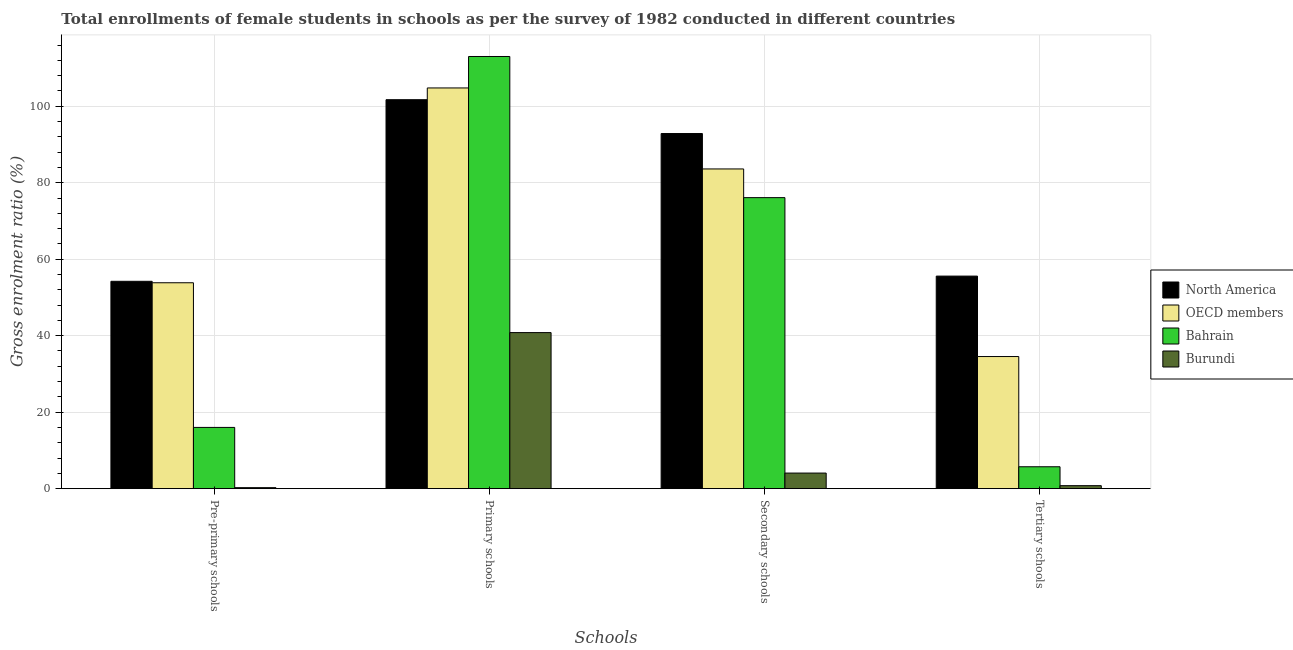Are the number of bars per tick equal to the number of legend labels?
Offer a terse response. Yes. How many bars are there on the 1st tick from the right?
Keep it short and to the point. 4. What is the label of the 4th group of bars from the left?
Ensure brevity in your answer.  Tertiary schools. What is the gross enrolment ratio(female) in primary schools in Burundi?
Keep it short and to the point. 40.81. Across all countries, what is the maximum gross enrolment ratio(female) in primary schools?
Provide a succinct answer. 113.01. Across all countries, what is the minimum gross enrolment ratio(female) in primary schools?
Give a very brief answer. 40.81. In which country was the gross enrolment ratio(female) in primary schools maximum?
Provide a short and direct response. Bahrain. In which country was the gross enrolment ratio(female) in secondary schools minimum?
Ensure brevity in your answer.  Burundi. What is the total gross enrolment ratio(female) in primary schools in the graph?
Offer a very short reply. 360.31. What is the difference between the gross enrolment ratio(female) in primary schools in North America and that in Burundi?
Ensure brevity in your answer.  60.9. What is the difference between the gross enrolment ratio(female) in primary schools in OECD members and the gross enrolment ratio(female) in secondary schools in Burundi?
Offer a very short reply. 100.7. What is the average gross enrolment ratio(female) in primary schools per country?
Make the answer very short. 90.08. What is the difference between the gross enrolment ratio(female) in tertiary schools and gross enrolment ratio(female) in pre-primary schools in Bahrain?
Your answer should be compact. -10.29. In how many countries, is the gross enrolment ratio(female) in pre-primary schools greater than 76 %?
Make the answer very short. 0. What is the ratio of the gross enrolment ratio(female) in secondary schools in North America to that in OECD members?
Give a very brief answer. 1.11. Is the difference between the gross enrolment ratio(female) in pre-primary schools in Burundi and North America greater than the difference between the gross enrolment ratio(female) in secondary schools in Burundi and North America?
Give a very brief answer. Yes. What is the difference between the highest and the second highest gross enrolment ratio(female) in pre-primary schools?
Your response must be concise. 0.38. What is the difference between the highest and the lowest gross enrolment ratio(female) in tertiary schools?
Provide a short and direct response. 54.8. In how many countries, is the gross enrolment ratio(female) in pre-primary schools greater than the average gross enrolment ratio(female) in pre-primary schools taken over all countries?
Make the answer very short. 2. Is it the case that in every country, the sum of the gross enrolment ratio(female) in primary schools and gross enrolment ratio(female) in pre-primary schools is greater than the sum of gross enrolment ratio(female) in secondary schools and gross enrolment ratio(female) in tertiary schools?
Your response must be concise. No. What does the 4th bar from the left in Primary schools represents?
Your answer should be very brief. Burundi. Are all the bars in the graph horizontal?
Keep it short and to the point. No. What is the difference between two consecutive major ticks on the Y-axis?
Your response must be concise. 20. Are the values on the major ticks of Y-axis written in scientific E-notation?
Make the answer very short. No. Does the graph contain any zero values?
Offer a very short reply. No. Does the graph contain grids?
Provide a short and direct response. Yes. What is the title of the graph?
Give a very brief answer. Total enrollments of female students in schools as per the survey of 1982 conducted in different countries. What is the label or title of the X-axis?
Offer a very short reply. Schools. What is the Gross enrolment ratio (%) in North America in Pre-primary schools?
Provide a succinct answer. 54.22. What is the Gross enrolment ratio (%) of OECD members in Pre-primary schools?
Ensure brevity in your answer.  53.84. What is the Gross enrolment ratio (%) of Bahrain in Pre-primary schools?
Keep it short and to the point. 16.02. What is the Gross enrolment ratio (%) in Burundi in Pre-primary schools?
Give a very brief answer. 0.26. What is the Gross enrolment ratio (%) of North America in Primary schools?
Provide a short and direct response. 101.71. What is the Gross enrolment ratio (%) of OECD members in Primary schools?
Your answer should be very brief. 104.78. What is the Gross enrolment ratio (%) of Bahrain in Primary schools?
Offer a terse response. 113.01. What is the Gross enrolment ratio (%) in Burundi in Primary schools?
Provide a succinct answer. 40.81. What is the Gross enrolment ratio (%) of North America in Secondary schools?
Keep it short and to the point. 92.86. What is the Gross enrolment ratio (%) in OECD members in Secondary schools?
Your answer should be compact. 83.6. What is the Gross enrolment ratio (%) of Bahrain in Secondary schools?
Your response must be concise. 76.1. What is the Gross enrolment ratio (%) of Burundi in Secondary schools?
Make the answer very short. 4.08. What is the Gross enrolment ratio (%) of North America in Tertiary schools?
Provide a succinct answer. 55.58. What is the Gross enrolment ratio (%) of OECD members in Tertiary schools?
Offer a terse response. 34.55. What is the Gross enrolment ratio (%) in Bahrain in Tertiary schools?
Your answer should be very brief. 5.73. What is the Gross enrolment ratio (%) in Burundi in Tertiary schools?
Offer a terse response. 0.79. Across all Schools, what is the maximum Gross enrolment ratio (%) of North America?
Provide a succinct answer. 101.71. Across all Schools, what is the maximum Gross enrolment ratio (%) in OECD members?
Keep it short and to the point. 104.78. Across all Schools, what is the maximum Gross enrolment ratio (%) of Bahrain?
Keep it short and to the point. 113.01. Across all Schools, what is the maximum Gross enrolment ratio (%) in Burundi?
Ensure brevity in your answer.  40.81. Across all Schools, what is the minimum Gross enrolment ratio (%) in North America?
Offer a very short reply. 54.22. Across all Schools, what is the minimum Gross enrolment ratio (%) of OECD members?
Give a very brief answer. 34.55. Across all Schools, what is the minimum Gross enrolment ratio (%) in Bahrain?
Provide a succinct answer. 5.73. Across all Schools, what is the minimum Gross enrolment ratio (%) in Burundi?
Your answer should be compact. 0.26. What is the total Gross enrolment ratio (%) of North America in the graph?
Offer a terse response. 304.38. What is the total Gross enrolment ratio (%) in OECD members in the graph?
Your answer should be very brief. 276.78. What is the total Gross enrolment ratio (%) of Bahrain in the graph?
Make the answer very short. 210.86. What is the total Gross enrolment ratio (%) in Burundi in the graph?
Make the answer very short. 45.94. What is the difference between the Gross enrolment ratio (%) in North America in Pre-primary schools and that in Primary schools?
Offer a terse response. -47.49. What is the difference between the Gross enrolment ratio (%) of OECD members in Pre-primary schools and that in Primary schools?
Make the answer very short. -50.94. What is the difference between the Gross enrolment ratio (%) in Bahrain in Pre-primary schools and that in Primary schools?
Make the answer very short. -96.99. What is the difference between the Gross enrolment ratio (%) of Burundi in Pre-primary schools and that in Primary schools?
Make the answer very short. -40.55. What is the difference between the Gross enrolment ratio (%) in North America in Pre-primary schools and that in Secondary schools?
Offer a terse response. -38.64. What is the difference between the Gross enrolment ratio (%) in OECD members in Pre-primary schools and that in Secondary schools?
Give a very brief answer. -29.76. What is the difference between the Gross enrolment ratio (%) in Bahrain in Pre-primary schools and that in Secondary schools?
Make the answer very short. -60.08. What is the difference between the Gross enrolment ratio (%) in Burundi in Pre-primary schools and that in Secondary schools?
Provide a succinct answer. -3.82. What is the difference between the Gross enrolment ratio (%) in North America in Pre-primary schools and that in Tertiary schools?
Your response must be concise. -1.36. What is the difference between the Gross enrolment ratio (%) in OECD members in Pre-primary schools and that in Tertiary schools?
Offer a terse response. 19.29. What is the difference between the Gross enrolment ratio (%) of Bahrain in Pre-primary schools and that in Tertiary schools?
Your answer should be very brief. 10.29. What is the difference between the Gross enrolment ratio (%) of Burundi in Pre-primary schools and that in Tertiary schools?
Offer a very short reply. -0.52. What is the difference between the Gross enrolment ratio (%) in North America in Primary schools and that in Secondary schools?
Your answer should be very brief. 8.85. What is the difference between the Gross enrolment ratio (%) in OECD members in Primary schools and that in Secondary schools?
Give a very brief answer. 21.18. What is the difference between the Gross enrolment ratio (%) of Bahrain in Primary schools and that in Secondary schools?
Your response must be concise. 36.91. What is the difference between the Gross enrolment ratio (%) of Burundi in Primary schools and that in Secondary schools?
Your answer should be compact. 36.73. What is the difference between the Gross enrolment ratio (%) in North America in Primary schools and that in Tertiary schools?
Offer a very short reply. 46.13. What is the difference between the Gross enrolment ratio (%) of OECD members in Primary schools and that in Tertiary schools?
Make the answer very short. 70.23. What is the difference between the Gross enrolment ratio (%) of Bahrain in Primary schools and that in Tertiary schools?
Offer a very short reply. 107.28. What is the difference between the Gross enrolment ratio (%) in Burundi in Primary schools and that in Tertiary schools?
Your answer should be very brief. 40.02. What is the difference between the Gross enrolment ratio (%) of North America in Secondary schools and that in Tertiary schools?
Provide a short and direct response. 37.28. What is the difference between the Gross enrolment ratio (%) in OECD members in Secondary schools and that in Tertiary schools?
Ensure brevity in your answer.  49.05. What is the difference between the Gross enrolment ratio (%) of Bahrain in Secondary schools and that in Tertiary schools?
Give a very brief answer. 70.37. What is the difference between the Gross enrolment ratio (%) of Burundi in Secondary schools and that in Tertiary schools?
Give a very brief answer. 3.3. What is the difference between the Gross enrolment ratio (%) in North America in Pre-primary schools and the Gross enrolment ratio (%) in OECD members in Primary schools?
Your answer should be compact. -50.56. What is the difference between the Gross enrolment ratio (%) of North America in Pre-primary schools and the Gross enrolment ratio (%) of Bahrain in Primary schools?
Provide a short and direct response. -58.79. What is the difference between the Gross enrolment ratio (%) of North America in Pre-primary schools and the Gross enrolment ratio (%) of Burundi in Primary schools?
Offer a very short reply. 13.41. What is the difference between the Gross enrolment ratio (%) in OECD members in Pre-primary schools and the Gross enrolment ratio (%) in Bahrain in Primary schools?
Offer a terse response. -59.17. What is the difference between the Gross enrolment ratio (%) in OECD members in Pre-primary schools and the Gross enrolment ratio (%) in Burundi in Primary schools?
Keep it short and to the point. 13.03. What is the difference between the Gross enrolment ratio (%) of Bahrain in Pre-primary schools and the Gross enrolment ratio (%) of Burundi in Primary schools?
Your answer should be compact. -24.79. What is the difference between the Gross enrolment ratio (%) in North America in Pre-primary schools and the Gross enrolment ratio (%) in OECD members in Secondary schools?
Make the answer very short. -29.38. What is the difference between the Gross enrolment ratio (%) in North America in Pre-primary schools and the Gross enrolment ratio (%) in Bahrain in Secondary schools?
Your answer should be very brief. -21.88. What is the difference between the Gross enrolment ratio (%) in North America in Pre-primary schools and the Gross enrolment ratio (%) in Burundi in Secondary schools?
Keep it short and to the point. 50.14. What is the difference between the Gross enrolment ratio (%) of OECD members in Pre-primary schools and the Gross enrolment ratio (%) of Bahrain in Secondary schools?
Keep it short and to the point. -22.26. What is the difference between the Gross enrolment ratio (%) of OECD members in Pre-primary schools and the Gross enrolment ratio (%) of Burundi in Secondary schools?
Keep it short and to the point. 49.76. What is the difference between the Gross enrolment ratio (%) in Bahrain in Pre-primary schools and the Gross enrolment ratio (%) in Burundi in Secondary schools?
Make the answer very short. 11.94. What is the difference between the Gross enrolment ratio (%) in North America in Pre-primary schools and the Gross enrolment ratio (%) in OECD members in Tertiary schools?
Ensure brevity in your answer.  19.67. What is the difference between the Gross enrolment ratio (%) in North America in Pre-primary schools and the Gross enrolment ratio (%) in Bahrain in Tertiary schools?
Your response must be concise. 48.49. What is the difference between the Gross enrolment ratio (%) of North America in Pre-primary schools and the Gross enrolment ratio (%) of Burundi in Tertiary schools?
Your response must be concise. 53.44. What is the difference between the Gross enrolment ratio (%) of OECD members in Pre-primary schools and the Gross enrolment ratio (%) of Bahrain in Tertiary schools?
Give a very brief answer. 48.11. What is the difference between the Gross enrolment ratio (%) in OECD members in Pre-primary schools and the Gross enrolment ratio (%) in Burundi in Tertiary schools?
Provide a short and direct response. 53.06. What is the difference between the Gross enrolment ratio (%) of Bahrain in Pre-primary schools and the Gross enrolment ratio (%) of Burundi in Tertiary schools?
Give a very brief answer. 15.23. What is the difference between the Gross enrolment ratio (%) in North America in Primary schools and the Gross enrolment ratio (%) in OECD members in Secondary schools?
Keep it short and to the point. 18.11. What is the difference between the Gross enrolment ratio (%) of North America in Primary schools and the Gross enrolment ratio (%) of Bahrain in Secondary schools?
Give a very brief answer. 25.61. What is the difference between the Gross enrolment ratio (%) in North America in Primary schools and the Gross enrolment ratio (%) in Burundi in Secondary schools?
Offer a terse response. 97.63. What is the difference between the Gross enrolment ratio (%) of OECD members in Primary schools and the Gross enrolment ratio (%) of Bahrain in Secondary schools?
Your answer should be very brief. 28.68. What is the difference between the Gross enrolment ratio (%) in OECD members in Primary schools and the Gross enrolment ratio (%) in Burundi in Secondary schools?
Provide a short and direct response. 100.7. What is the difference between the Gross enrolment ratio (%) of Bahrain in Primary schools and the Gross enrolment ratio (%) of Burundi in Secondary schools?
Ensure brevity in your answer.  108.93. What is the difference between the Gross enrolment ratio (%) in North America in Primary schools and the Gross enrolment ratio (%) in OECD members in Tertiary schools?
Provide a succinct answer. 67.16. What is the difference between the Gross enrolment ratio (%) of North America in Primary schools and the Gross enrolment ratio (%) of Bahrain in Tertiary schools?
Offer a very short reply. 95.98. What is the difference between the Gross enrolment ratio (%) in North America in Primary schools and the Gross enrolment ratio (%) in Burundi in Tertiary schools?
Provide a succinct answer. 100.92. What is the difference between the Gross enrolment ratio (%) of OECD members in Primary schools and the Gross enrolment ratio (%) of Bahrain in Tertiary schools?
Give a very brief answer. 99.05. What is the difference between the Gross enrolment ratio (%) in OECD members in Primary schools and the Gross enrolment ratio (%) in Burundi in Tertiary schools?
Your answer should be compact. 104. What is the difference between the Gross enrolment ratio (%) of Bahrain in Primary schools and the Gross enrolment ratio (%) of Burundi in Tertiary schools?
Give a very brief answer. 112.22. What is the difference between the Gross enrolment ratio (%) of North America in Secondary schools and the Gross enrolment ratio (%) of OECD members in Tertiary schools?
Make the answer very short. 58.31. What is the difference between the Gross enrolment ratio (%) in North America in Secondary schools and the Gross enrolment ratio (%) in Bahrain in Tertiary schools?
Ensure brevity in your answer.  87.13. What is the difference between the Gross enrolment ratio (%) in North America in Secondary schools and the Gross enrolment ratio (%) in Burundi in Tertiary schools?
Make the answer very short. 92.07. What is the difference between the Gross enrolment ratio (%) in OECD members in Secondary schools and the Gross enrolment ratio (%) in Bahrain in Tertiary schools?
Your answer should be very brief. 77.87. What is the difference between the Gross enrolment ratio (%) of OECD members in Secondary schools and the Gross enrolment ratio (%) of Burundi in Tertiary schools?
Provide a succinct answer. 82.82. What is the difference between the Gross enrolment ratio (%) in Bahrain in Secondary schools and the Gross enrolment ratio (%) in Burundi in Tertiary schools?
Ensure brevity in your answer.  75.32. What is the average Gross enrolment ratio (%) of North America per Schools?
Ensure brevity in your answer.  76.09. What is the average Gross enrolment ratio (%) in OECD members per Schools?
Provide a succinct answer. 69.2. What is the average Gross enrolment ratio (%) in Bahrain per Schools?
Offer a very short reply. 52.72. What is the average Gross enrolment ratio (%) of Burundi per Schools?
Give a very brief answer. 11.49. What is the difference between the Gross enrolment ratio (%) of North America and Gross enrolment ratio (%) of OECD members in Pre-primary schools?
Provide a short and direct response. 0.38. What is the difference between the Gross enrolment ratio (%) in North America and Gross enrolment ratio (%) in Bahrain in Pre-primary schools?
Give a very brief answer. 38.2. What is the difference between the Gross enrolment ratio (%) of North America and Gross enrolment ratio (%) of Burundi in Pre-primary schools?
Make the answer very short. 53.96. What is the difference between the Gross enrolment ratio (%) in OECD members and Gross enrolment ratio (%) in Bahrain in Pre-primary schools?
Give a very brief answer. 37.82. What is the difference between the Gross enrolment ratio (%) of OECD members and Gross enrolment ratio (%) of Burundi in Pre-primary schools?
Give a very brief answer. 53.58. What is the difference between the Gross enrolment ratio (%) in Bahrain and Gross enrolment ratio (%) in Burundi in Pre-primary schools?
Offer a terse response. 15.76. What is the difference between the Gross enrolment ratio (%) in North America and Gross enrolment ratio (%) in OECD members in Primary schools?
Offer a terse response. -3.07. What is the difference between the Gross enrolment ratio (%) of North America and Gross enrolment ratio (%) of Bahrain in Primary schools?
Ensure brevity in your answer.  -11.3. What is the difference between the Gross enrolment ratio (%) of North America and Gross enrolment ratio (%) of Burundi in Primary schools?
Provide a succinct answer. 60.9. What is the difference between the Gross enrolment ratio (%) of OECD members and Gross enrolment ratio (%) of Bahrain in Primary schools?
Your answer should be compact. -8.23. What is the difference between the Gross enrolment ratio (%) in OECD members and Gross enrolment ratio (%) in Burundi in Primary schools?
Your response must be concise. 63.97. What is the difference between the Gross enrolment ratio (%) in Bahrain and Gross enrolment ratio (%) in Burundi in Primary schools?
Provide a succinct answer. 72.2. What is the difference between the Gross enrolment ratio (%) of North America and Gross enrolment ratio (%) of OECD members in Secondary schools?
Provide a succinct answer. 9.26. What is the difference between the Gross enrolment ratio (%) in North America and Gross enrolment ratio (%) in Bahrain in Secondary schools?
Keep it short and to the point. 16.76. What is the difference between the Gross enrolment ratio (%) in North America and Gross enrolment ratio (%) in Burundi in Secondary schools?
Keep it short and to the point. 88.78. What is the difference between the Gross enrolment ratio (%) of OECD members and Gross enrolment ratio (%) of Bahrain in Secondary schools?
Your response must be concise. 7.5. What is the difference between the Gross enrolment ratio (%) of OECD members and Gross enrolment ratio (%) of Burundi in Secondary schools?
Give a very brief answer. 79.52. What is the difference between the Gross enrolment ratio (%) of Bahrain and Gross enrolment ratio (%) of Burundi in Secondary schools?
Make the answer very short. 72.02. What is the difference between the Gross enrolment ratio (%) in North America and Gross enrolment ratio (%) in OECD members in Tertiary schools?
Provide a succinct answer. 21.03. What is the difference between the Gross enrolment ratio (%) in North America and Gross enrolment ratio (%) in Bahrain in Tertiary schools?
Give a very brief answer. 49.85. What is the difference between the Gross enrolment ratio (%) of North America and Gross enrolment ratio (%) of Burundi in Tertiary schools?
Offer a terse response. 54.8. What is the difference between the Gross enrolment ratio (%) in OECD members and Gross enrolment ratio (%) in Bahrain in Tertiary schools?
Provide a short and direct response. 28.82. What is the difference between the Gross enrolment ratio (%) of OECD members and Gross enrolment ratio (%) of Burundi in Tertiary schools?
Your answer should be compact. 33.76. What is the difference between the Gross enrolment ratio (%) of Bahrain and Gross enrolment ratio (%) of Burundi in Tertiary schools?
Your response must be concise. 4.94. What is the ratio of the Gross enrolment ratio (%) of North America in Pre-primary schools to that in Primary schools?
Ensure brevity in your answer.  0.53. What is the ratio of the Gross enrolment ratio (%) in OECD members in Pre-primary schools to that in Primary schools?
Your response must be concise. 0.51. What is the ratio of the Gross enrolment ratio (%) in Bahrain in Pre-primary schools to that in Primary schools?
Your answer should be compact. 0.14. What is the ratio of the Gross enrolment ratio (%) in Burundi in Pre-primary schools to that in Primary schools?
Offer a very short reply. 0.01. What is the ratio of the Gross enrolment ratio (%) of North America in Pre-primary schools to that in Secondary schools?
Offer a very short reply. 0.58. What is the ratio of the Gross enrolment ratio (%) of OECD members in Pre-primary schools to that in Secondary schools?
Keep it short and to the point. 0.64. What is the ratio of the Gross enrolment ratio (%) of Bahrain in Pre-primary schools to that in Secondary schools?
Provide a short and direct response. 0.21. What is the ratio of the Gross enrolment ratio (%) of Burundi in Pre-primary schools to that in Secondary schools?
Provide a short and direct response. 0.06. What is the ratio of the Gross enrolment ratio (%) of North America in Pre-primary schools to that in Tertiary schools?
Make the answer very short. 0.98. What is the ratio of the Gross enrolment ratio (%) of OECD members in Pre-primary schools to that in Tertiary schools?
Make the answer very short. 1.56. What is the ratio of the Gross enrolment ratio (%) of Bahrain in Pre-primary schools to that in Tertiary schools?
Provide a short and direct response. 2.8. What is the ratio of the Gross enrolment ratio (%) in Burundi in Pre-primary schools to that in Tertiary schools?
Make the answer very short. 0.33. What is the ratio of the Gross enrolment ratio (%) in North America in Primary schools to that in Secondary schools?
Make the answer very short. 1.1. What is the ratio of the Gross enrolment ratio (%) of OECD members in Primary schools to that in Secondary schools?
Provide a succinct answer. 1.25. What is the ratio of the Gross enrolment ratio (%) in Bahrain in Primary schools to that in Secondary schools?
Provide a short and direct response. 1.49. What is the ratio of the Gross enrolment ratio (%) in Burundi in Primary schools to that in Secondary schools?
Your response must be concise. 10. What is the ratio of the Gross enrolment ratio (%) in North America in Primary schools to that in Tertiary schools?
Your response must be concise. 1.83. What is the ratio of the Gross enrolment ratio (%) in OECD members in Primary schools to that in Tertiary schools?
Keep it short and to the point. 3.03. What is the ratio of the Gross enrolment ratio (%) in Bahrain in Primary schools to that in Tertiary schools?
Provide a succinct answer. 19.72. What is the ratio of the Gross enrolment ratio (%) in Burundi in Primary schools to that in Tertiary schools?
Make the answer very short. 51.9. What is the ratio of the Gross enrolment ratio (%) in North America in Secondary schools to that in Tertiary schools?
Give a very brief answer. 1.67. What is the ratio of the Gross enrolment ratio (%) of OECD members in Secondary schools to that in Tertiary schools?
Your answer should be compact. 2.42. What is the ratio of the Gross enrolment ratio (%) of Bahrain in Secondary schools to that in Tertiary schools?
Your answer should be compact. 13.28. What is the ratio of the Gross enrolment ratio (%) of Burundi in Secondary schools to that in Tertiary schools?
Keep it short and to the point. 5.19. What is the difference between the highest and the second highest Gross enrolment ratio (%) of North America?
Provide a succinct answer. 8.85. What is the difference between the highest and the second highest Gross enrolment ratio (%) of OECD members?
Provide a succinct answer. 21.18. What is the difference between the highest and the second highest Gross enrolment ratio (%) in Bahrain?
Provide a short and direct response. 36.91. What is the difference between the highest and the second highest Gross enrolment ratio (%) of Burundi?
Your answer should be compact. 36.73. What is the difference between the highest and the lowest Gross enrolment ratio (%) in North America?
Provide a succinct answer. 47.49. What is the difference between the highest and the lowest Gross enrolment ratio (%) of OECD members?
Your answer should be compact. 70.23. What is the difference between the highest and the lowest Gross enrolment ratio (%) of Bahrain?
Your answer should be very brief. 107.28. What is the difference between the highest and the lowest Gross enrolment ratio (%) of Burundi?
Give a very brief answer. 40.55. 